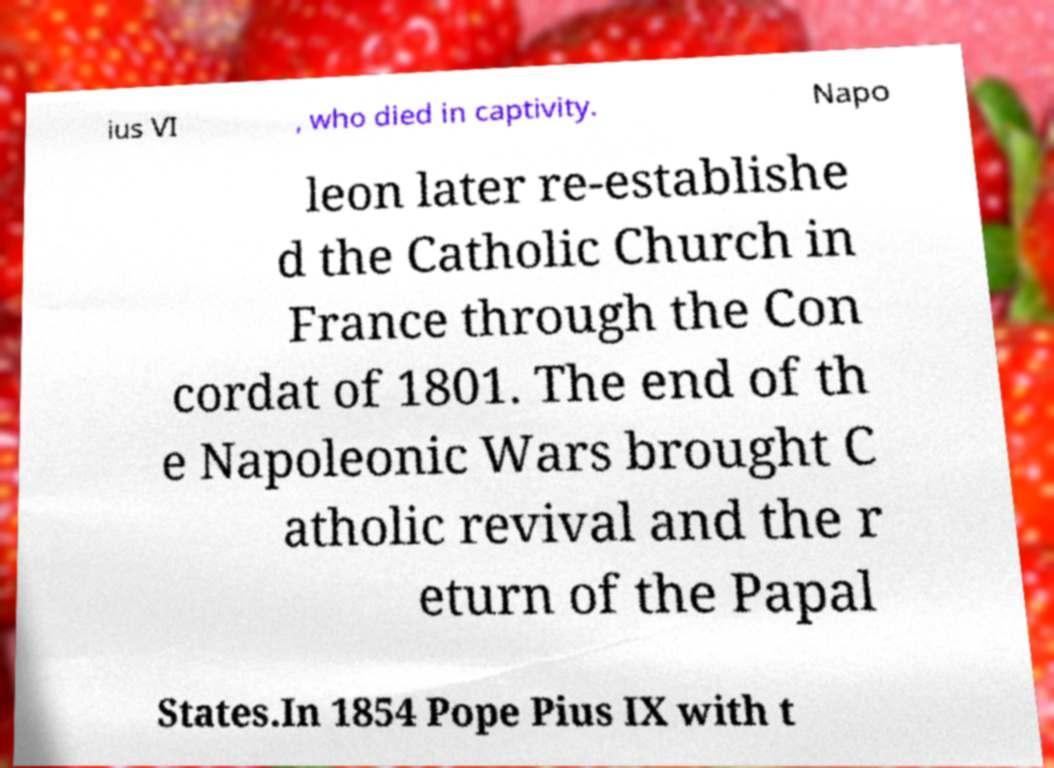Could you assist in decoding the text presented in this image and type it out clearly? ius VI , who died in captivity. Napo leon later re-establishe d the Catholic Church in France through the Con cordat of 1801. The end of th e Napoleonic Wars brought C atholic revival and the r eturn of the Papal States.In 1854 Pope Pius IX with t 